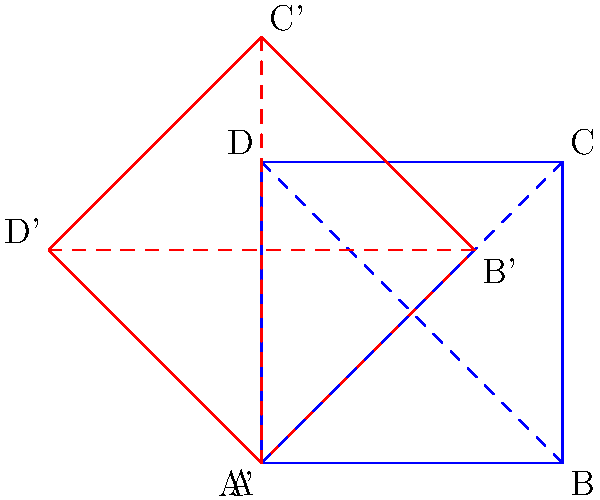In this Masonic-inspired architectural design, two interlocking squares are shown. The blue square represents the foundation, while the red square represents a rotated element. If the blue square has a side length of 1 unit, what is the area of the overlapping region between the two squares? To solve this problem, let's follow these steps:

1) First, we need to recognize that the red square is rotated 45° relative to the blue square.

2) The overlapping region forms an octagon at the center of the diagram.

3) This octagon can be divided into 8 congruent right triangles.

4) To find the area of one of these triangles, we need to determine its base and height.

5) The base of each triangle is half the side length of the blue square. So, the base is 0.5 units.

6) The height of each triangle is the perpendicular distance from the midpoint of a side of the blue square to the corresponding side of the red square.

7) This height can be calculated using the formula: $h = \frac{\sqrt{2}-1}{2}$

8) The area of one triangle is thus: $A_{triangle} = \frac{1}{2} * 0.5 * \frac{\sqrt{2}-1}{2} = \frac{\sqrt{2}-1}{8}$

9) Since there are 8 such triangles, the total area of the octagon is:

   $A_{octagon} = 8 * \frac{\sqrt{2}-1}{8} = \sqrt{2}-1$

Therefore, the area of the overlapping region is $\sqrt{2}-1$ square units.
Answer: $\sqrt{2}-1$ square units 